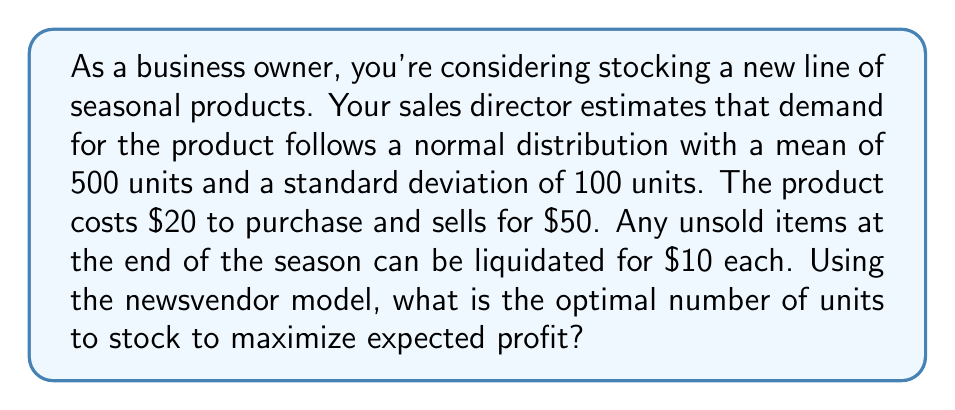Help me with this question. To solve this problem using the newsvendor model, we'll follow these steps:

1. Identify the critical ratio (CR):
   CR = (Price - Cost) / (Price - Salvage Value)
   $$ CR = \frac{50 - 20}{50 - 10} = \frac{30}{40} = 0.75 $$

2. Find the z-score corresponding to the CR using the standard normal distribution:
   For CR = 0.75, z ≈ 0.6745 (This can be found using a standard normal table or calculator)

3. Calculate the optimal inventory level:
   $$ Q^* = \mu + z\sigma $$
   Where:
   $\mu$ = mean demand = 500
   $\sigma$ = standard deviation of demand = 100
   z = 0.6745

   $$ Q^* = 500 + (0.6745 * 100) = 500 + 67.45 = 567.45 $$

4. Round to the nearest whole number, as we can't stock fractional units:
   Optimal inventory level = 567 units

This inventory level balances the risk of overstocking (and having to liquidate unsold items) with the risk of understocking (and missing potential sales), maximizing expected profit given the demand distribution and financial parameters.
Answer: The optimal number of units to stock is 567. 